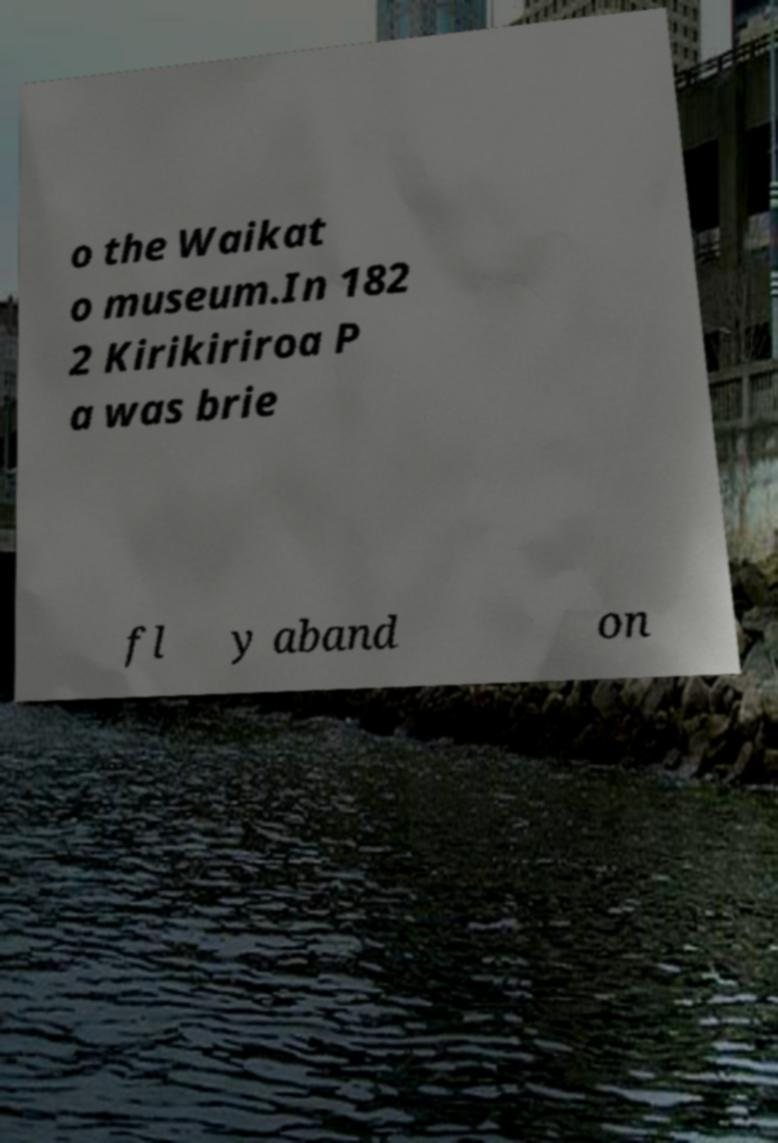Could you extract and type out the text from this image? o the Waikat o museum.In 182 2 Kirikiriroa P a was brie fl y aband on 